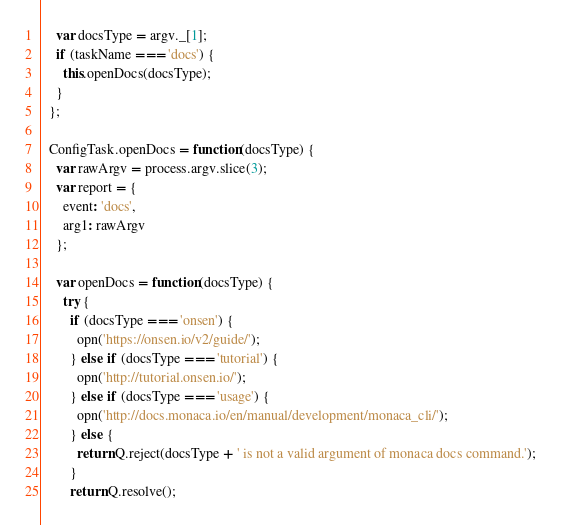<code> <loc_0><loc_0><loc_500><loc_500><_JavaScript_>    var docsType = argv._[1];
    if (taskName === 'docs') {
      this.openDocs(docsType);
    }
  };

  ConfigTask.openDocs = function(docsType) {
    var rawArgv = process.argv.slice(3);
    var report = {
      event: 'docs',
      arg1: rawArgv
    };

    var openDocs = function(docsType) {
      try {
        if (docsType === 'onsen') {
          opn('https://onsen.io/v2/guide/');
        } else if (docsType === 'tutorial') {
          opn('http://tutorial.onsen.io/');
        } else if (docsType === 'usage') {
          opn('http://docs.monaca.io/en/manual/development/monaca_cli/');
        } else {
          return Q.reject(docsType + ' is not a valid argument of monaca docs command.');
        }
        return Q.resolve();</code> 